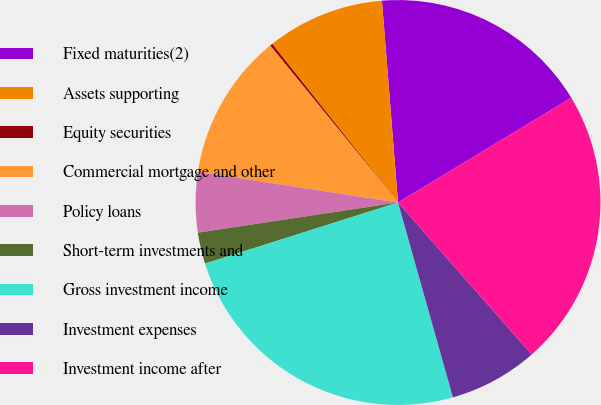Convert chart. <chart><loc_0><loc_0><loc_500><loc_500><pie_chart><fcel>Fixed maturities(2)<fcel>Assets supporting<fcel>Equity securities<fcel>Commercial mortgage and other<fcel>Policy loans<fcel>Short-term investments and<fcel>Gross investment income<fcel>Investment expenses<fcel>Investment income after<nl><fcel>17.61%<fcel>9.41%<fcel>0.2%<fcel>11.71%<fcel>4.8%<fcel>2.5%<fcel>24.49%<fcel>7.11%<fcel>22.18%<nl></chart> 